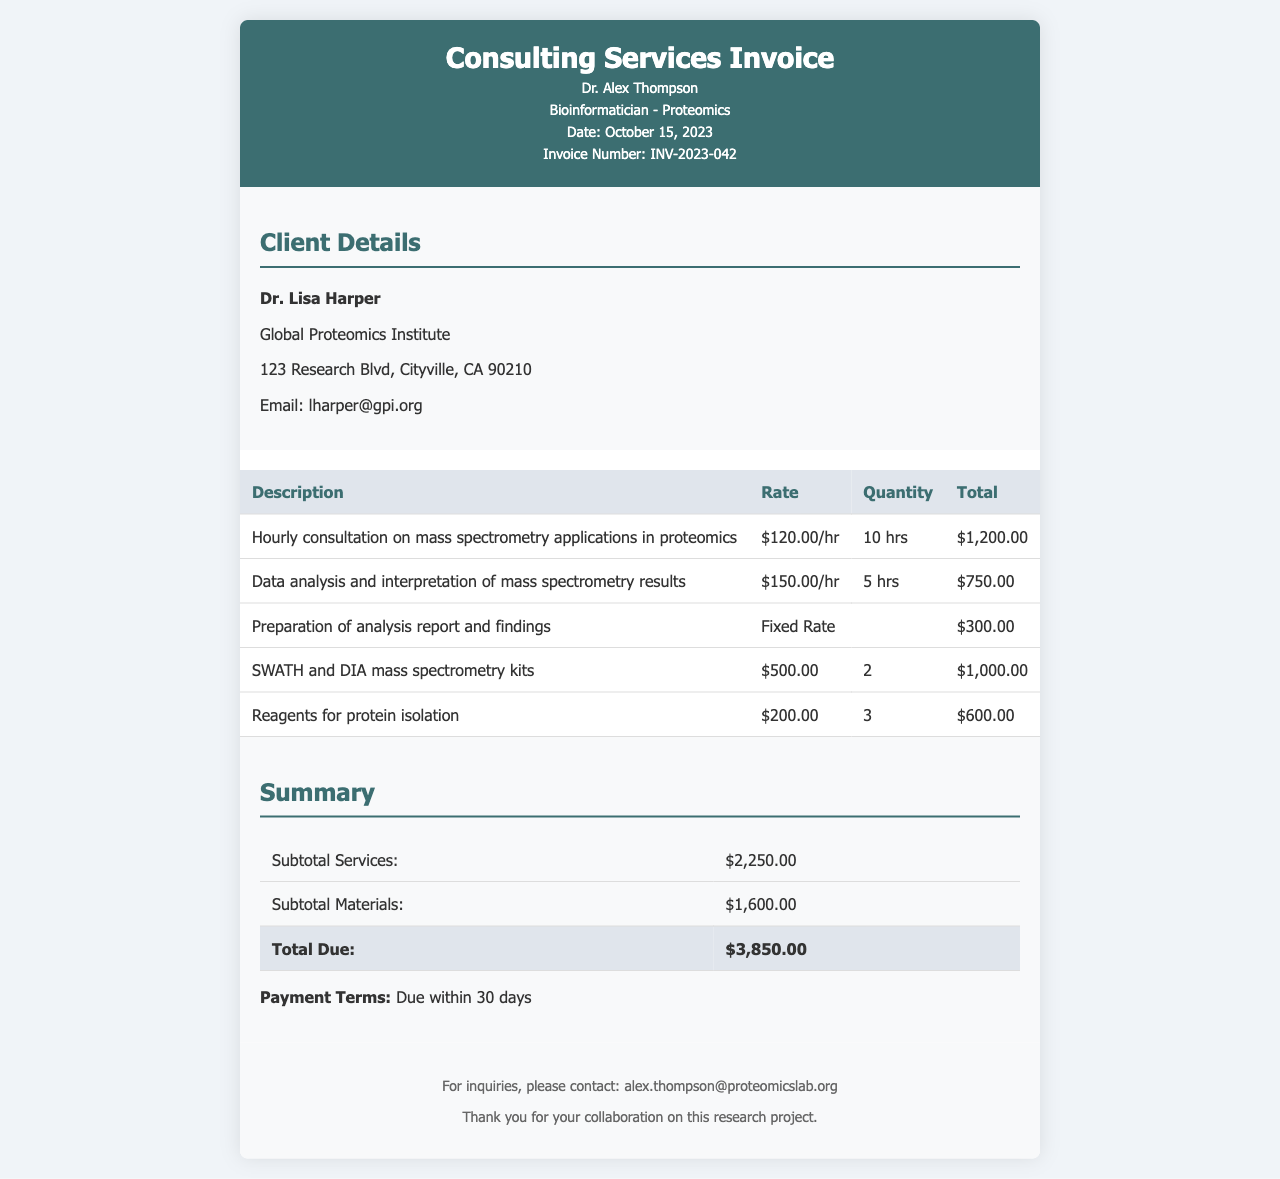What is the date of the invoice? The date of the invoice is explicitly stated in the document as October 15, 2023.
Answer: October 15, 2023 Who is the client? The client's name is provided in the client details section of the document.
Answer: Dr. Lisa Harper What is the hourly rate for data analysis? The document specifies the hourly rate for data analysis and interpretation as $150.00/hr.
Answer: $150.00/hr How many hours were charged for hourly consultation? The number of hours for the hourly consultation is listed in the document, which totals 10 hours.
Answer: 10 hrs What is the total due amount? The total due amount is calculated and presented in the summary section of the invoice.
Answer: $3,850.00 What is the fixed rate for the preparation of the analysis report? The document explicitly states the fixed rate for this service as $300.00.
Answer: $300.00 How many SWATH and DIA mass spectrometry kits were billed? The invoice indicates the quantity of SWATH and DIA mass spectrometry kits billed.
Answer: 2 What is the payment term mentioned in the invoice? The payment terms are clearly defined in the summary section of the invoice.
Answer: Due within 30 days What is the subtotal for materials? The subtotal for materials is provided in the summary of the invoice.
Answer: $1,600.00 